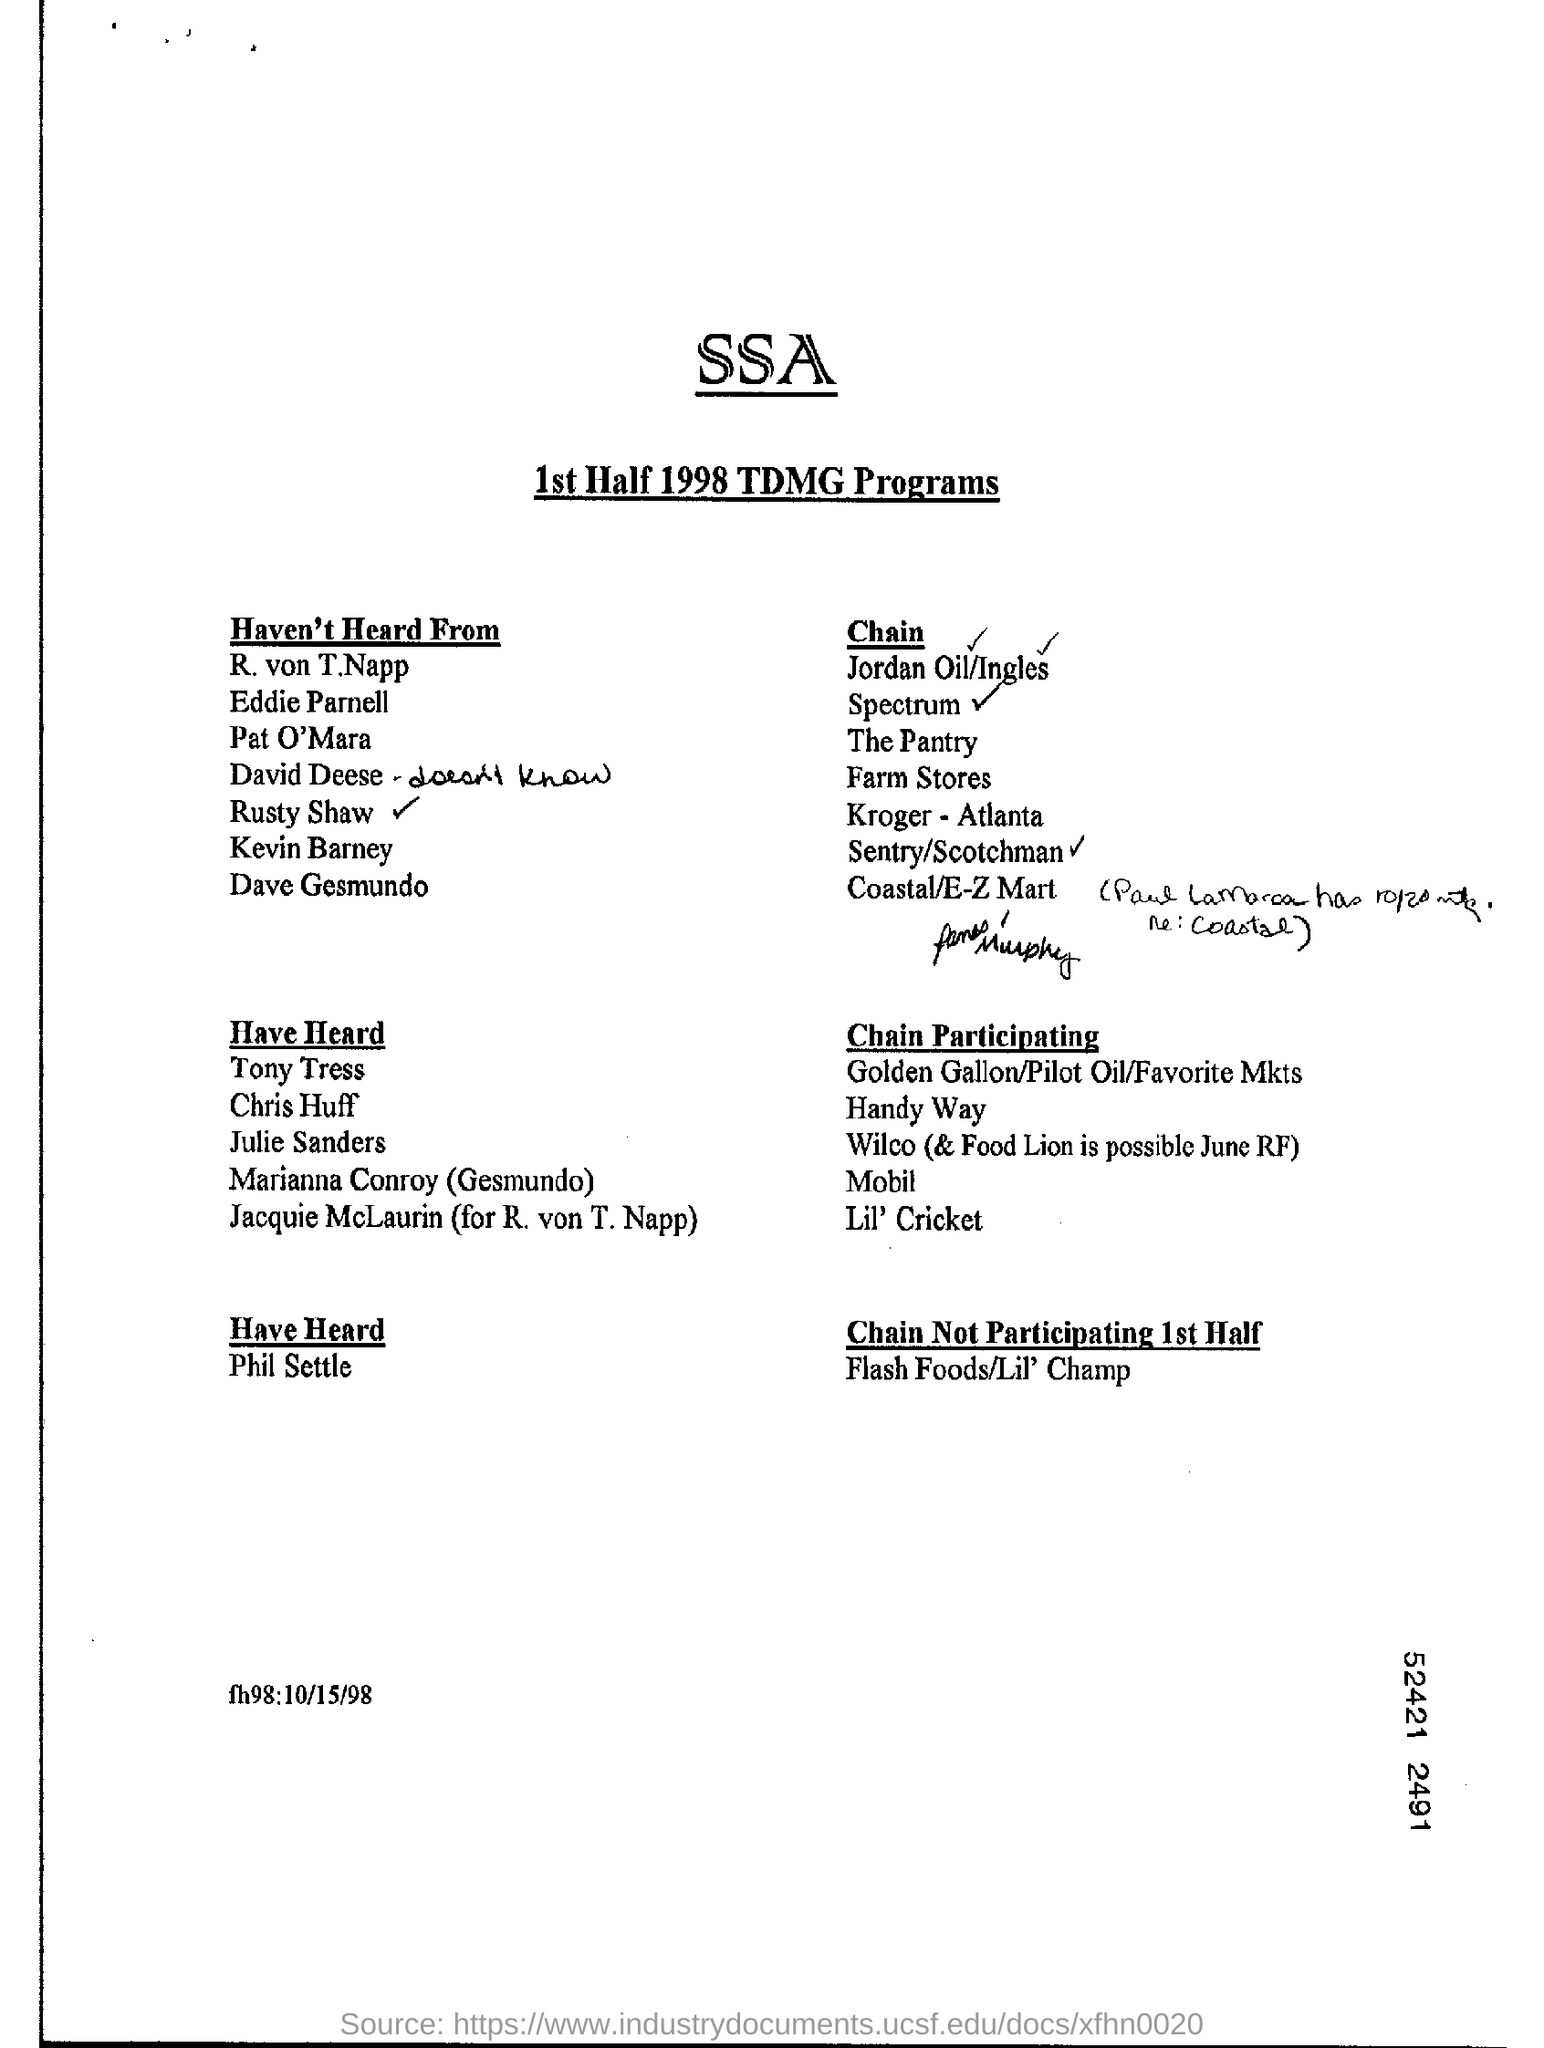Who is the first person in the 'haven't heard from' list?
Make the answer very short. R. von T.Napp. What is the main heading?
Keep it short and to the point. SSA. 